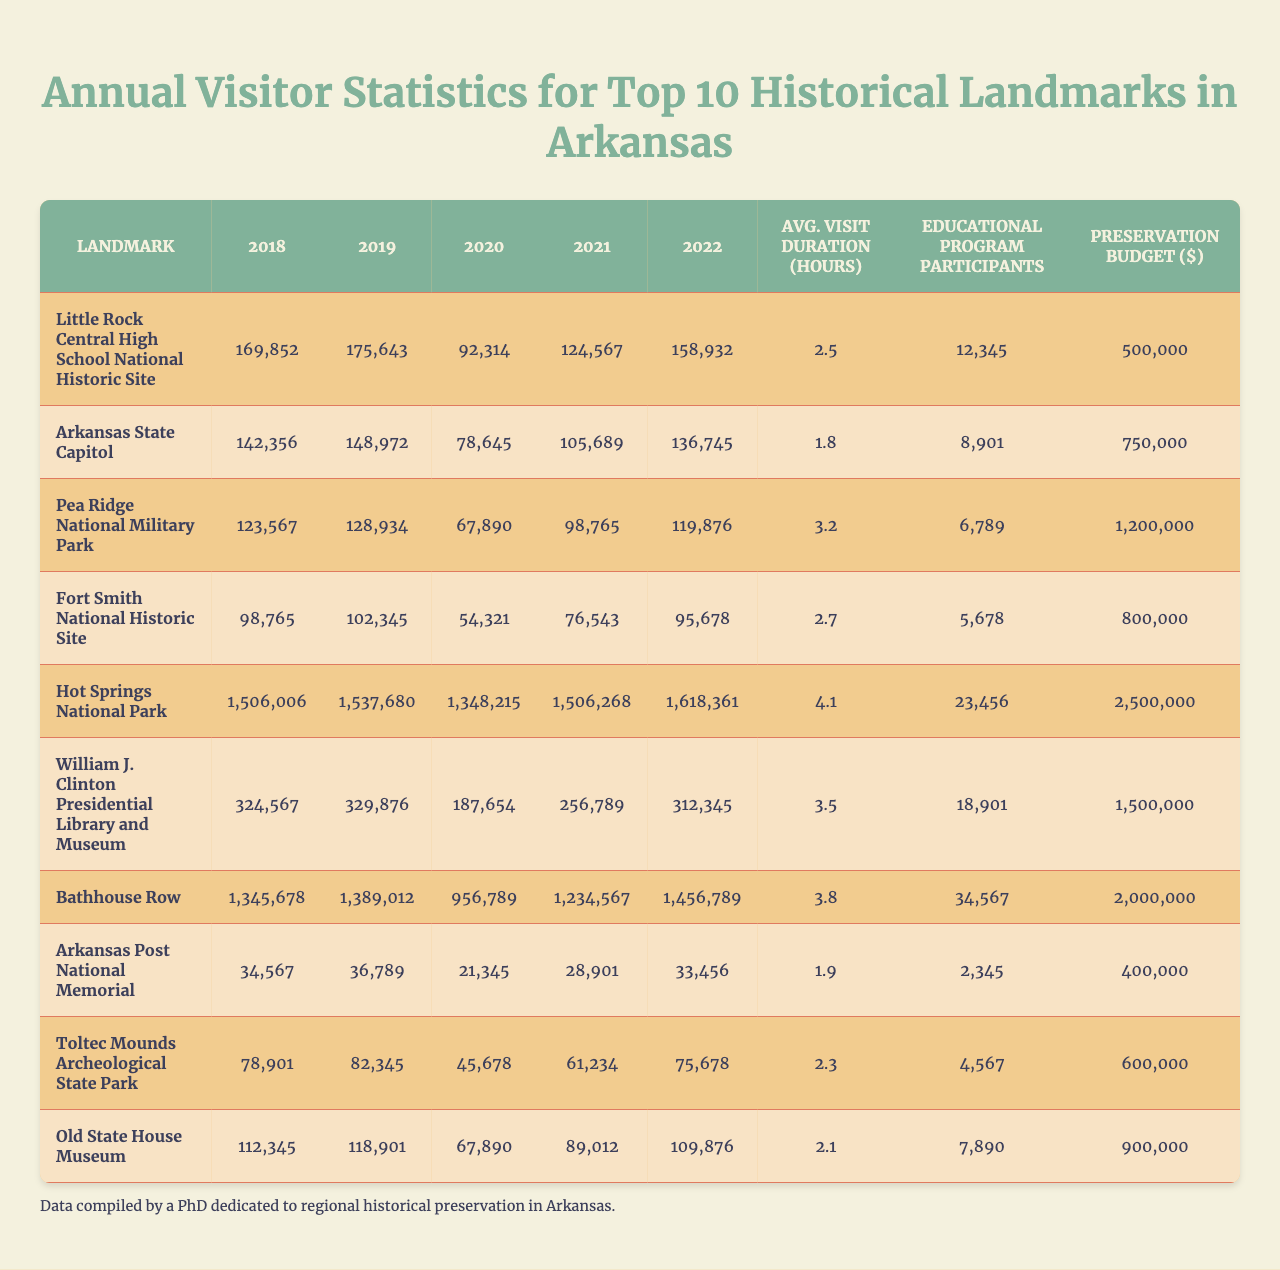What was the total number of visitors to the Arkansas State Capitol in 2022? Referring to the table, the visitor data for the Arkansas State Capitol in 2022 is found in the corresponding row and column, which shows 136,745 visitors.
Answer: 136,745 Which landmark had the highest average visit duration? By reviewing the average visit duration column, it shows that Bathhouse Row has the longest average visit duration of 3.8 hours.
Answer: Bathhouse Row What was the visitor count at Fort Smith National Historic Site in 2020? The table indicates that the number of visitors to Fort Smith National Historic Site in 2020 is 54,321, found in the respective row and column.
Answer: 54,321 How many more visitors did Hot Springs National Park have in 2021 compared to 2020? The visitor count for Hot Springs National Park in 2021 is 1,506,268, while in 2020 it was 1,348,215. Calculating the difference: 1,506,268 - 1,348,215 = 158,053.
Answer: 158,053 Did the number of educational program participants at Pea Ridge National Military Park exceed 10,000? The educational program participants for Pea Ridge National Military Park are 6,789, which is less than 10,000. Therefore, the answer is no.
Answer: No Which landmark saw the most significant increase in visitor numbers from 2018 to 2022? The comparison shows that Hot Springs National Park increased from 1,506,006 in 2018 to 1,618,361 in 2022, a rise of 112,355 visitors. This is the highest among all landmarks when calculated.
Answer: Hot Springs National Park What is the total preservation budget for all the landmarks combined? By adding all the preservation budgets: 500,000 + 750,000 + 1,200,000 + 800,000 + 2,500,000 + 1,500,000 + 2,000,000 + 400,000 + 600,000 + 900,000 = 12,300,000.
Answer: 12,300,000 Is the average visit duration at the Old State House Museum greater than 2 hours? The average visit duration for the Old State House Museum is 2.1 hours, which is indeed greater than 2 hours.
Answer: Yes Which landmark had the least number of visitors in 2021 and how many were there? The smallest visitor count in 2021 is for Pea Ridge National Military Park, which had 98,765 visitors, as seen in the table.
Answer: Pea Ridge National Military Park, 98,765 What is the average visitor count across all landmarks in 2019? To find the overall average for 2019, sum all visitor numbers for that year: 175,643 + 148,972 + 128,934 + 102,345 + 1,537,680 + 329,876 + 1,389,012 + 36,789 + 82,345 + 118,901 = 3,418,095; dividing by 10 gives an average of 341,809.5 visitors.
Answer: 341,809.5 If educational program participation at Bathhouse Row increased by 2,000 in the following year, what would be the new total? Bathhouse Row currently has 34,567 participants. Adding 2,000 gives 34,567 + 2,000 = 36,567. Hence, the new total would be 36,567.
Answer: 36,567 